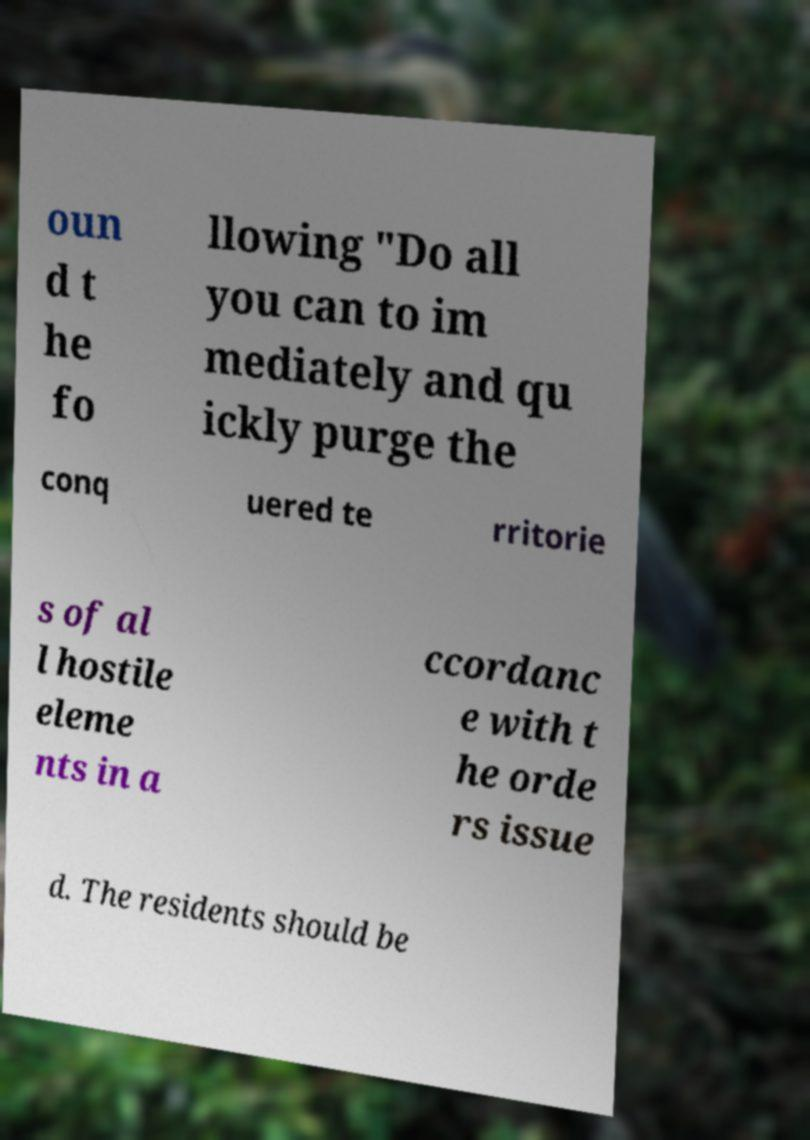I need the written content from this picture converted into text. Can you do that? oun d t he fo llowing "Do all you can to im mediately and qu ickly purge the conq uered te rritorie s of al l hostile eleme nts in a ccordanc e with t he orde rs issue d. The residents should be 